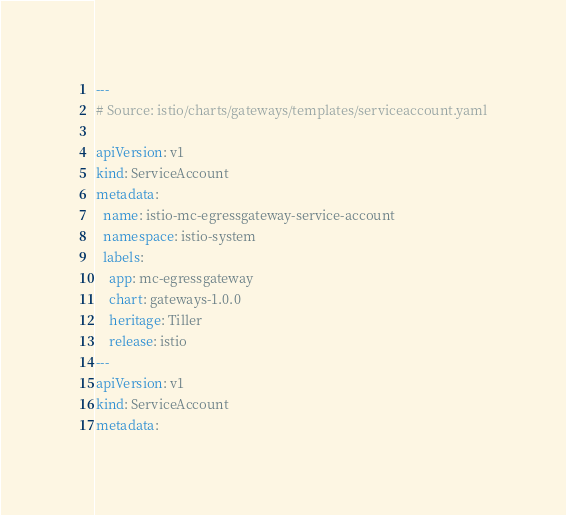Convert code to text. <code><loc_0><loc_0><loc_500><loc_500><_YAML_>---
# Source: istio/charts/gateways/templates/serviceaccount.yaml

apiVersion: v1
kind: ServiceAccount
metadata:
  name: istio-mc-egressgateway-service-account
  namespace: istio-system
  labels:
    app: mc-egressgateway
    chart: gateways-1.0.0
    heritage: Tiller
    release: istio
---
apiVersion: v1
kind: ServiceAccount
metadata:</code> 